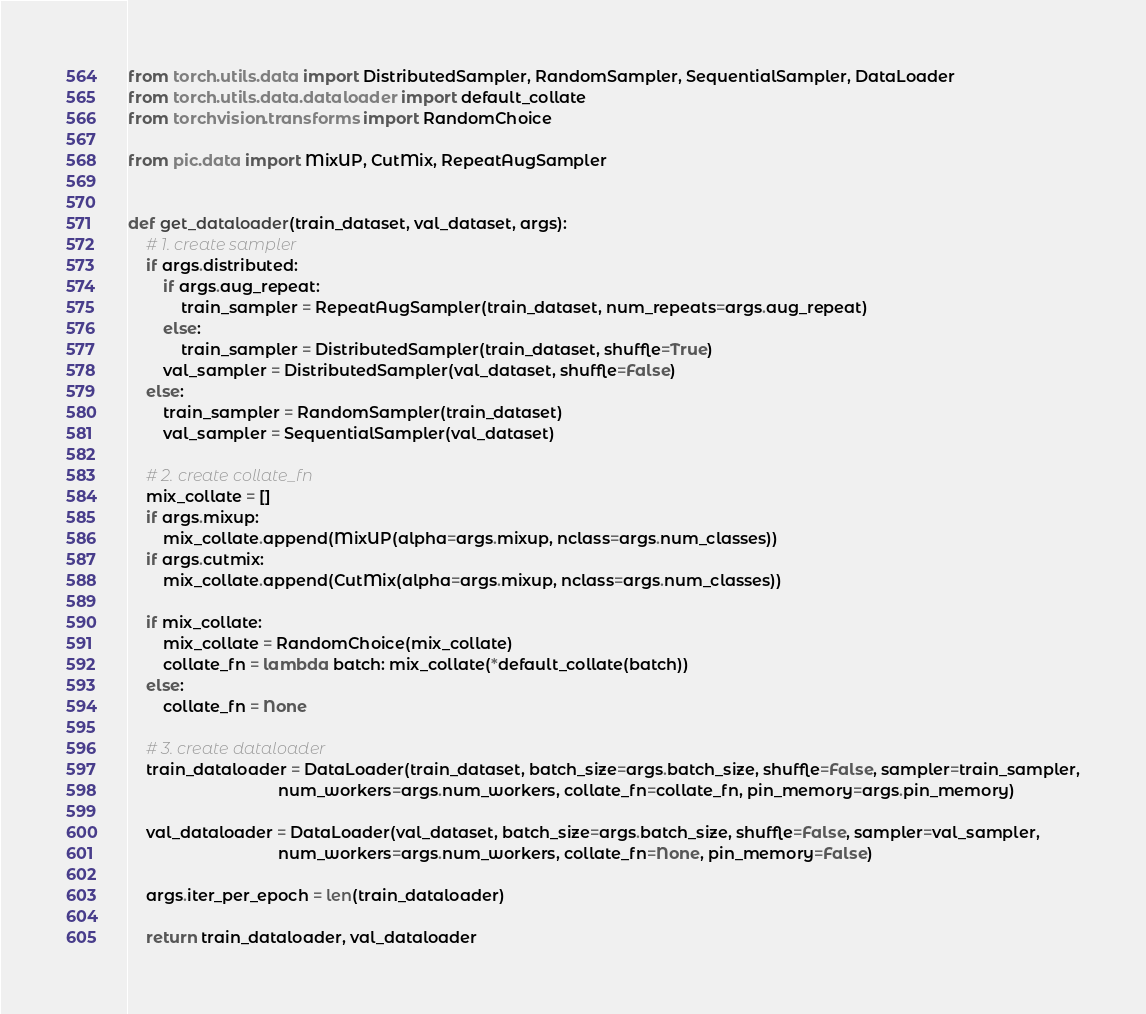Convert code to text. <code><loc_0><loc_0><loc_500><loc_500><_Python_>from torch.utils.data import DistributedSampler, RandomSampler, SequentialSampler, DataLoader
from torch.utils.data.dataloader import default_collate
from torchvision.transforms import RandomChoice

from pic.data import MixUP, CutMix, RepeatAugSampler


def get_dataloader(train_dataset, val_dataset, args):
    # 1. create sampler
    if args.distributed:
        if args.aug_repeat:
            train_sampler = RepeatAugSampler(train_dataset, num_repeats=args.aug_repeat)
        else:
            train_sampler = DistributedSampler(train_dataset, shuffle=True)
        val_sampler = DistributedSampler(val_dataset, shuffle=False)
    else:
        train_sampler = RandomSampler(train_dataset)
        val_sampler = SequentialSampler(val_dataset)

    # 2. create collate_fn
    mix_collate = []
    if args.mixup:
        mix_collate.append(MixUP(alpha=args.mixup, nclass=args.num_classes))
    if args.cutmix:
        mix_collate.append(CutMix(alpha=args.mixup, nclass=args.num_classes))

    if mix_collate:
        mix_collate = RandomChoice(mix_collate)
        collate_fn = lambda batch: mix_collate(*default_collate(batch))
    else:
        collate_fn = None

    # 3. create dataloader
    train_dataloader = DataLoader(train_dataset, batch_size=args.batch_size, shuffle=False, sampler=train_sampler,
                                  num_workers=args.num_workers, collate_fn=collate_fn, pin_memory=args.pin_memory)

    val_dataloader = DataLoader(val_dataset, batch_size=args.batch_size, shuffle=False, sampler=val_sampler,
                                  num_workers=args.num_workers, collate_fn=None, pin_memory=False)

    args.iter_per_epoch = len(train_dataloader)

    return train_dataloader, val_dataloader
</code> 